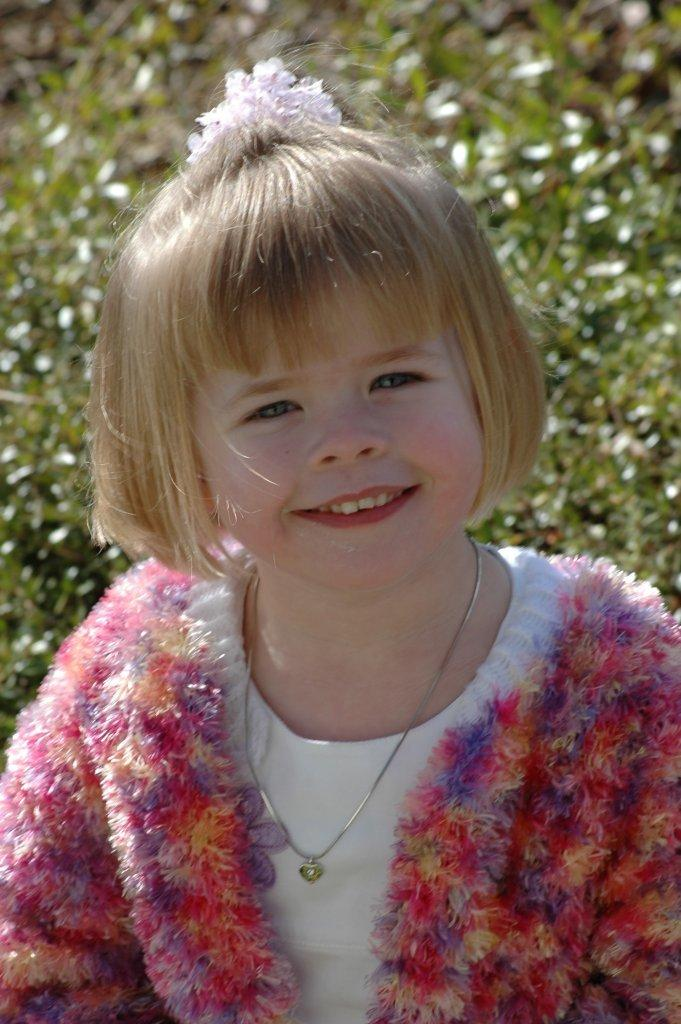Who is the main subject in the image? There is a girl in the image. What is the girl wearing? The girl is wearing clothes and a neck chain. What is the girl's facial expression in the image? The girl is smiling. What type of environment is visible in the image? There is grass visible in the image. How would you describe the background of the image? The background of the image is slightly blurred. What type of government is depicted in the image? There is no depiction of a government in the image; it features a girl with a smile and grass in the background. How many mines are visible in the image? There are no mines present in the image. 